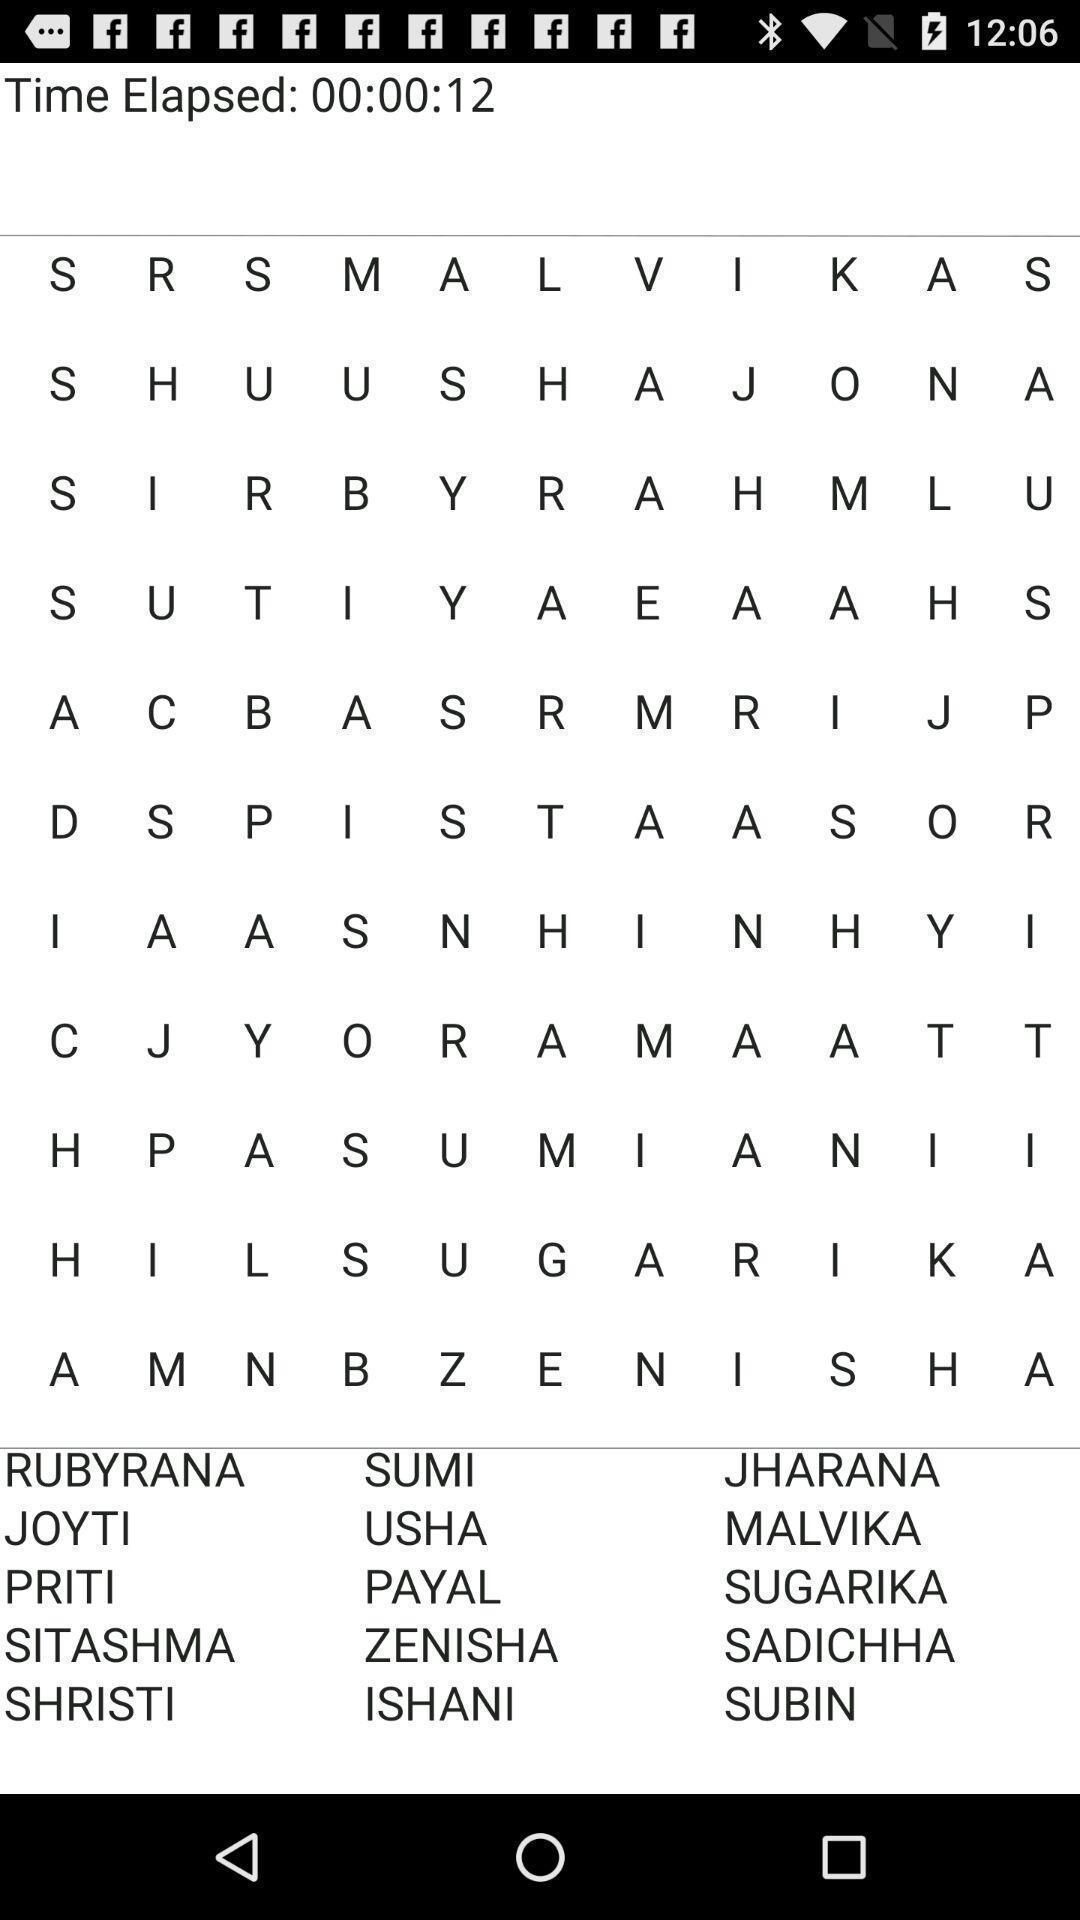What details can you identify in this image? Screen displays the alphabets in the word puzzle. 